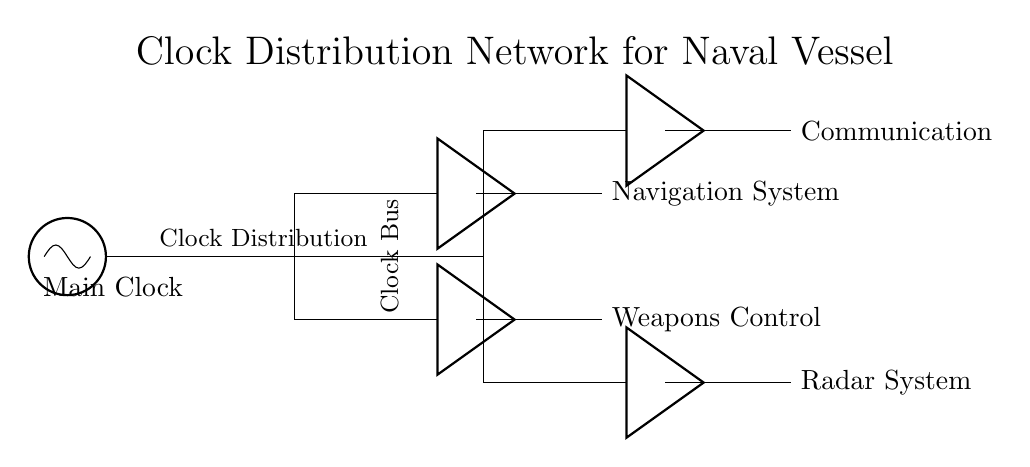What is the main component in this clock distribution network? The main component is the oscillator, which generates the primary clock signal for synchronization across the systems.
Answer: oscillator How many systems are connected to the clock distribution network? There are four systems connected: Navigation System, Weapons Control, Communication, and Radar System.
Answer: four What type of components are used to strengthen the clock signals? The circuit uses buffers to amplify and strengthen the clock signals before distributing them to various systems.
Answer: buffers What role does the clock bus play in this circuit? The clock bus acts as a shared channel that distributes the clock signal from the main source to multiple systems, ensuring proper synchronization.
Answer: shared channel Which two systems are directly connected to the first buffer? The first buffer connects to the Navigation System and the Weapons Control system.
Answer: Navigation System, Weapons Control How many total buffers are used in the circuit diagram? There are four buffers in total, each serving to strengthen the clock signals for different systems.
Answer: four What is the function of the oscillator in this circuit? The oscillator generates the clock signal, which is essential for timing and synchronization throughout the electronic systems on the vessel.
Answer: generate clock signal 